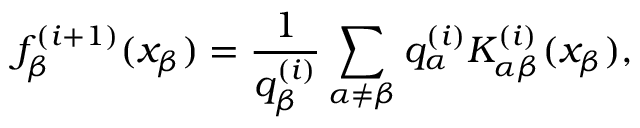<formula> <loc_0><loc_0><loc_500><loc_500>f _ { \beta } ^ { ( i + 1 ) } ( x _ { \beta } ) = \frac { 1 } { q _ { \beta } ^ { ( i ) } } \sum _ { \alpha \neq \beta } q _ { \alpha } ^ { ( i ) } K _ { \alpha \beta } ^ { ( i ) } ( x _ { \beta } ) ,</formula> 